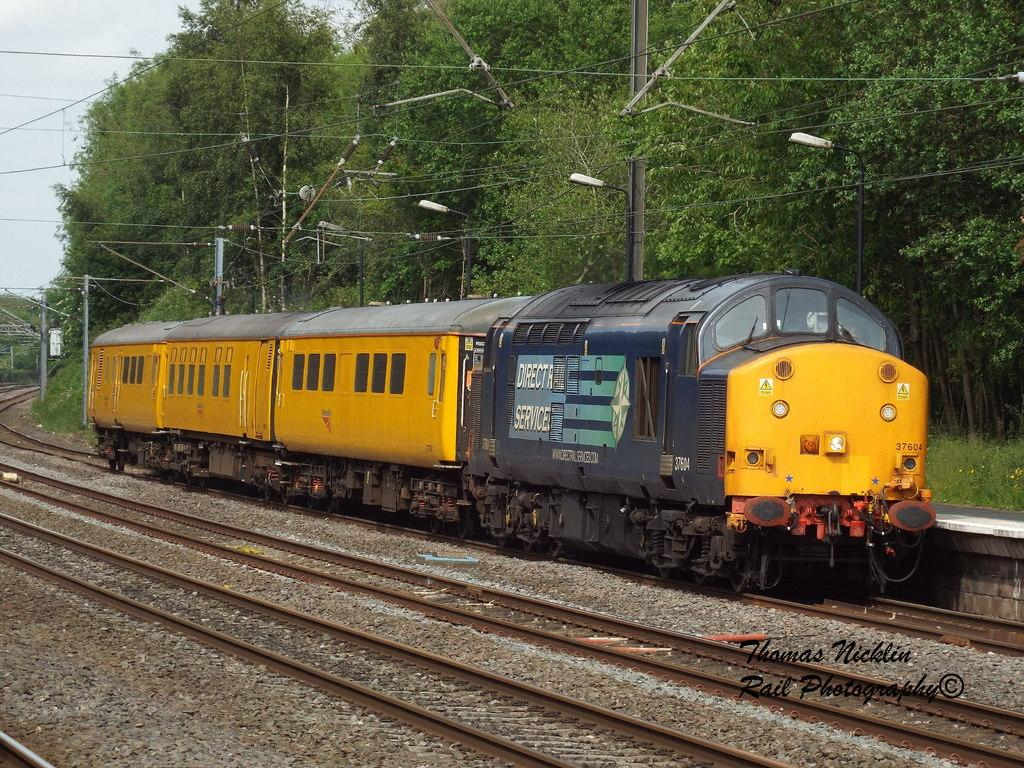What is the main subject of the image? The main subject of the image is a train. Where is the train located in the image? The train is on a railway track. What else can be seen in the image besides the train? There are poles, trees, and the sky visible in the image. Can you see a rabbit riding on the train in the image? No, there is no rabbit or any other animal visible on the train in the image. What type of boat can be seen in the image? There is no boat present in the image; it features a train on a railway track. 